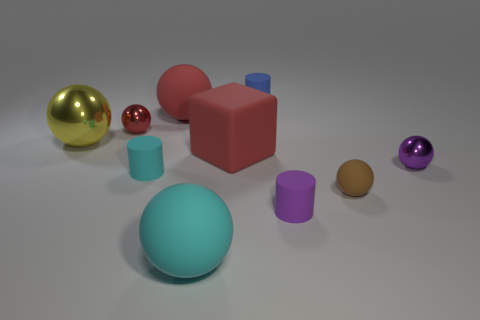Is the size of the metallic sphere that is on the right side of the blue object the same as the small blue matte cylinder?
Offer a terse response. Yes. There is a ball that is both left of the brown matte object and in front of the big cube; what is its size?
Offer a very short reply. Large. There is a big sphere that is the same color as the big block; what is its material?
Your response must be concise. Rubber. What number of tiny spheres are the same color as the matte block?
Offer a terse response. 1. Is the number of small brown matte objects that are behind the matte block the same as the number of blue metallic objects?
Ensure brevity in your answer.  Yes. The small rubber ball has what color?
Keep it short and to the point. Brown. There is a cyan sphere that is made of the same material as the purple cylinder; what size is it?
Keep it short and to the point. Large. The cube that is the same material as the tiny brown object is what color?
Give a very brief answer. Red. Is there a purple rubber object of the same size as the blue object?
Make the answer very short. Yes. What is the material of the large yellow object that is the same shape as the tiny red metal object?
Provide a short and direct response. Metal. 